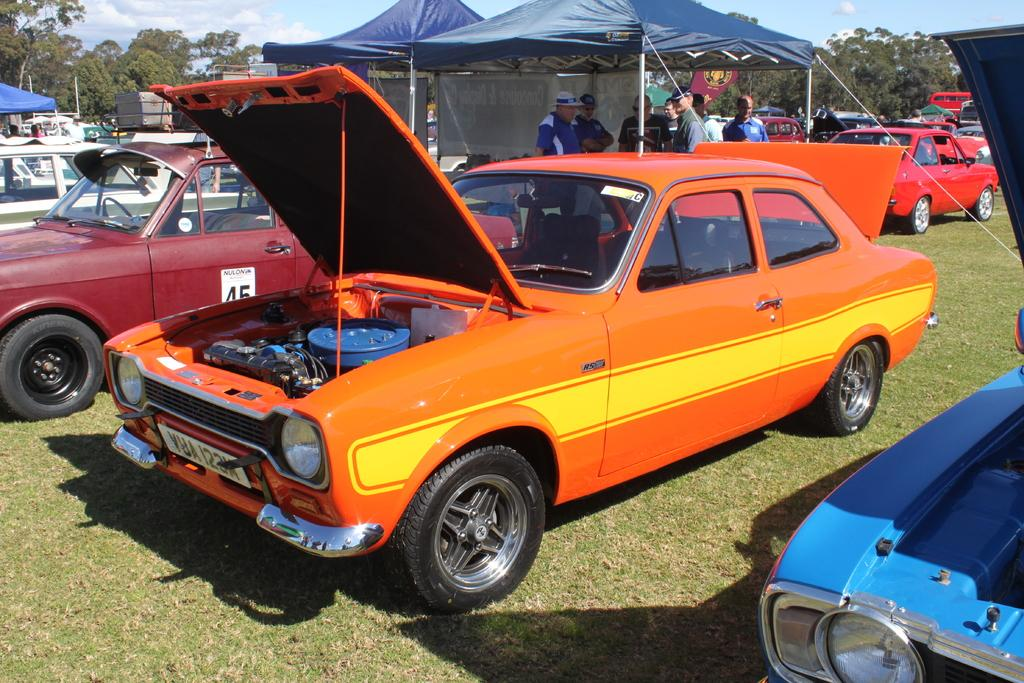What type of vehicles can be seen in the image? There are cars in the image. What are the people in the image doing? There are persons standing on the ground in the image. What type of temporary shelters are present in the image? There are tents in the image. What type of signage is visible in the image? There are banners in the image. What type of vegetation is present in the image? There are trees in the image. What is visible in the background of the image? The sky is visible in the background of the image, and clouds are present in the sky. What type of crime is being committed in the image? There is no indication of any crime being committed in the image. What type of silk material is draped over the tents in the image? There is no silk material present in the image; the tents are not described as having any specific fabric. 